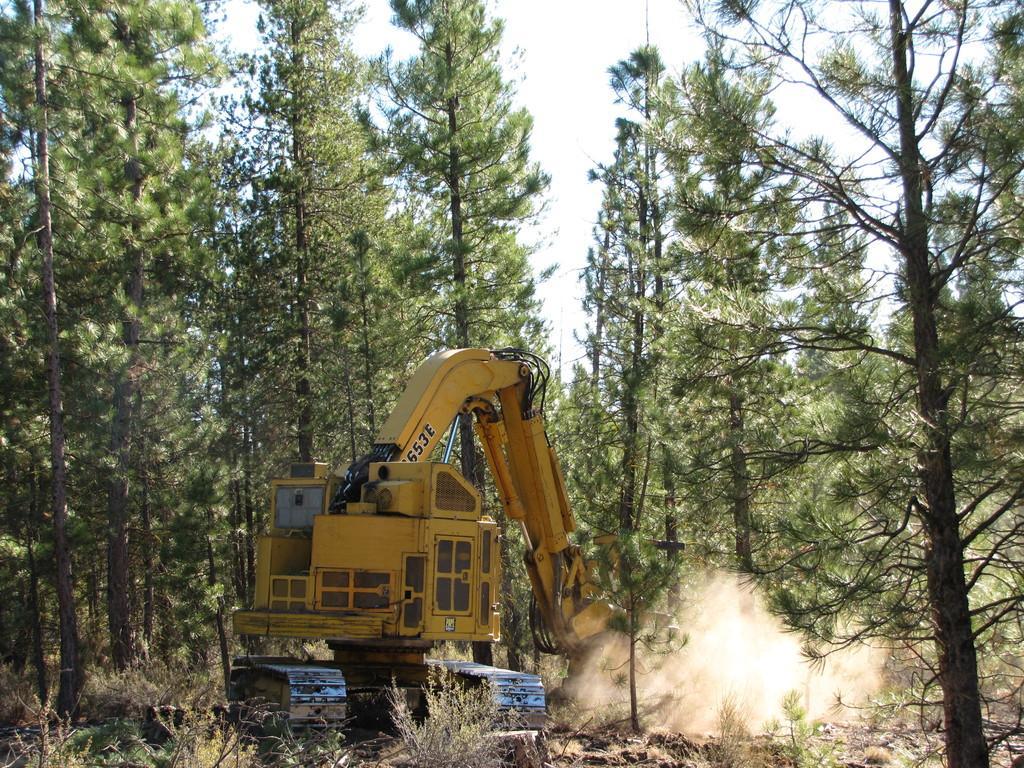In one or two sentences, can you explain what this image depicts? In this image I can see the vehicle and the vehicle is in yellow color, background I can see trees in green color and the sky is in white color. 